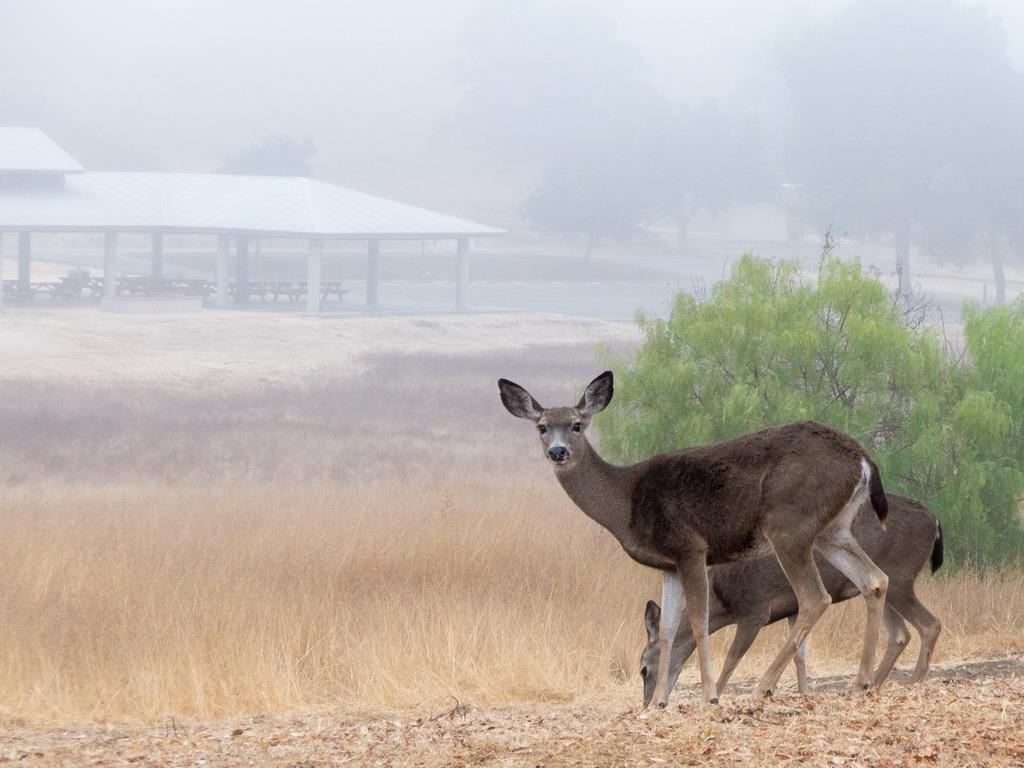What is the visual effect on the background of the image? The background portion of the picture is blurred. What type of vegetation can be seen in the background? There are trees visible in the background. What type of structure is present in the image? There is a shed in the image. How many animals are in the image? There are two animals in the image. Can you tell me where the creator of the image is standing in the seashore? There is no information about a creator or a seashore in the image, so we cannot determine their location. 